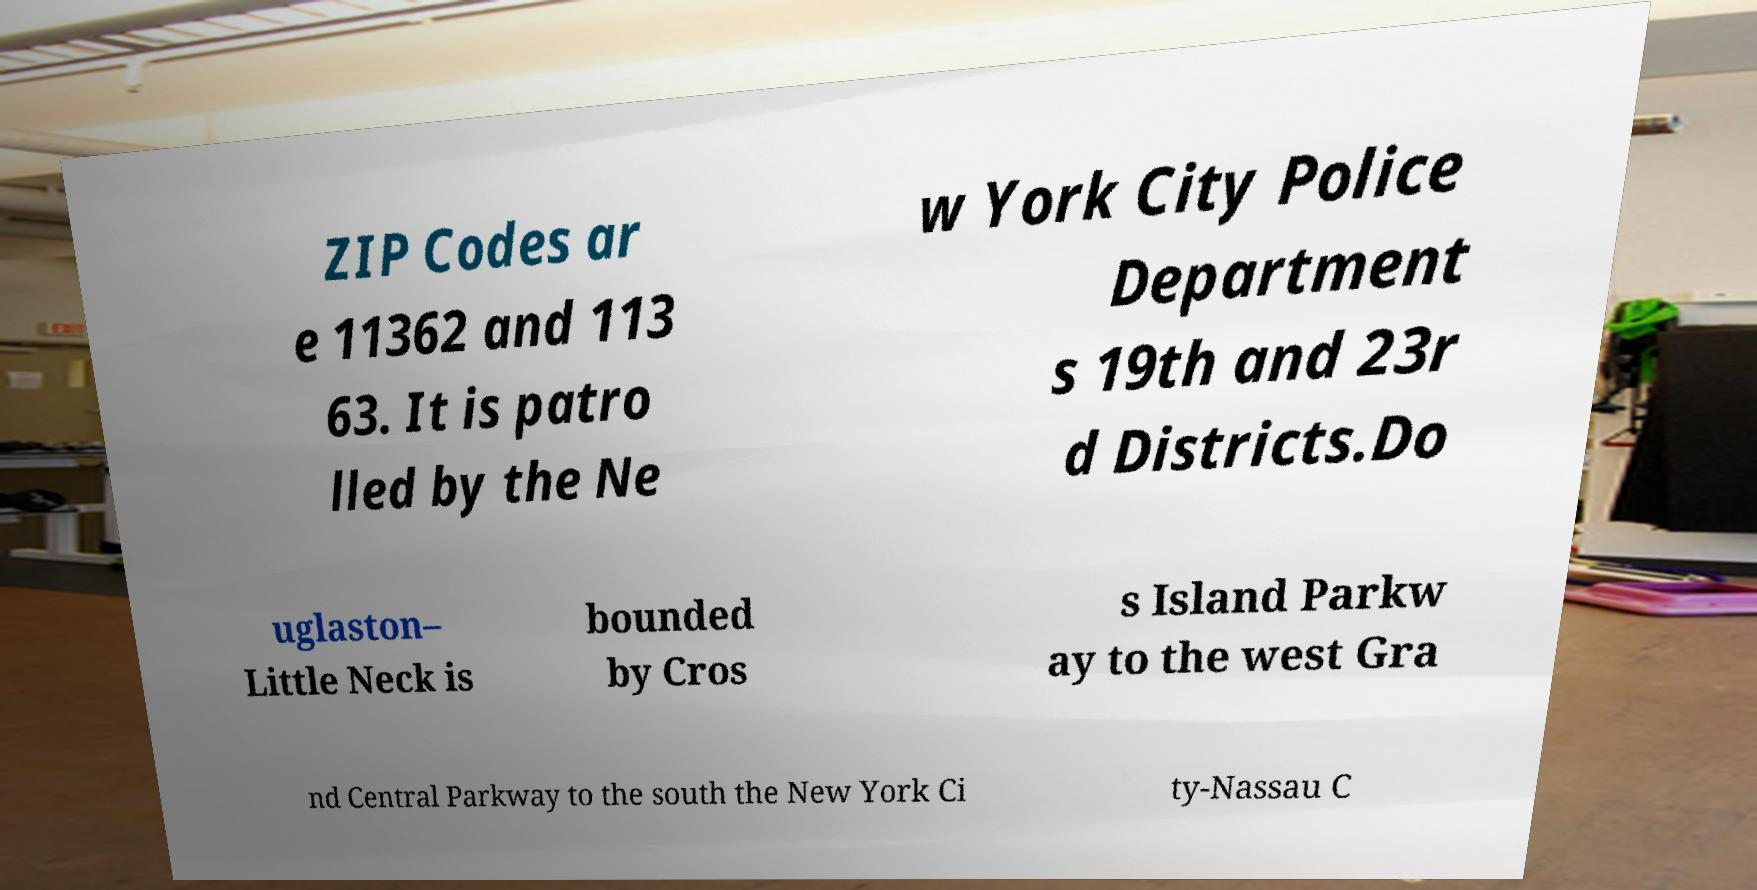I need the written content from this picture converted into text. Can you do that? ZIP Codes ar e 11362 and 113 63. It is patro lled by the Ne w York City Police Department s 19th and 23r d Districts.Do uglaston– Little Neck is bounded by Cros s Island Parkw ay to the west Gra nd Central Parkway to the south the New York Ci ty-Nassau C 